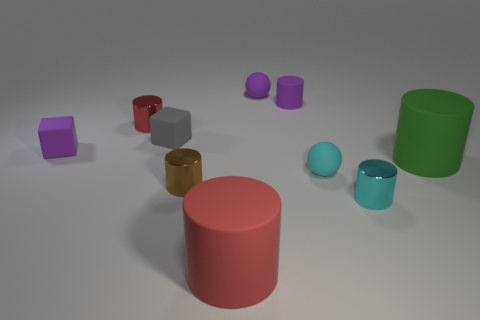Subtract all purple cylinders. How many cylinders are left? 5 Subtract all tiny brown cylinders. How many cylinders are left? 5 Subtract all purple cylinders. Subtract all brown blocks. How many cylinders are left? 5 Subtract all balls. How many objects are left? 8 Add 3 large red matte cylinders. How many large red matte cylinders exist? 4 Subtract 1 purple balls. How many objects are left? 9 Subtract all large red things. Subtract all matte spheres. How many objects are left? 7 Add 1 tiny red objects. How many tiny red objects are left? 2 